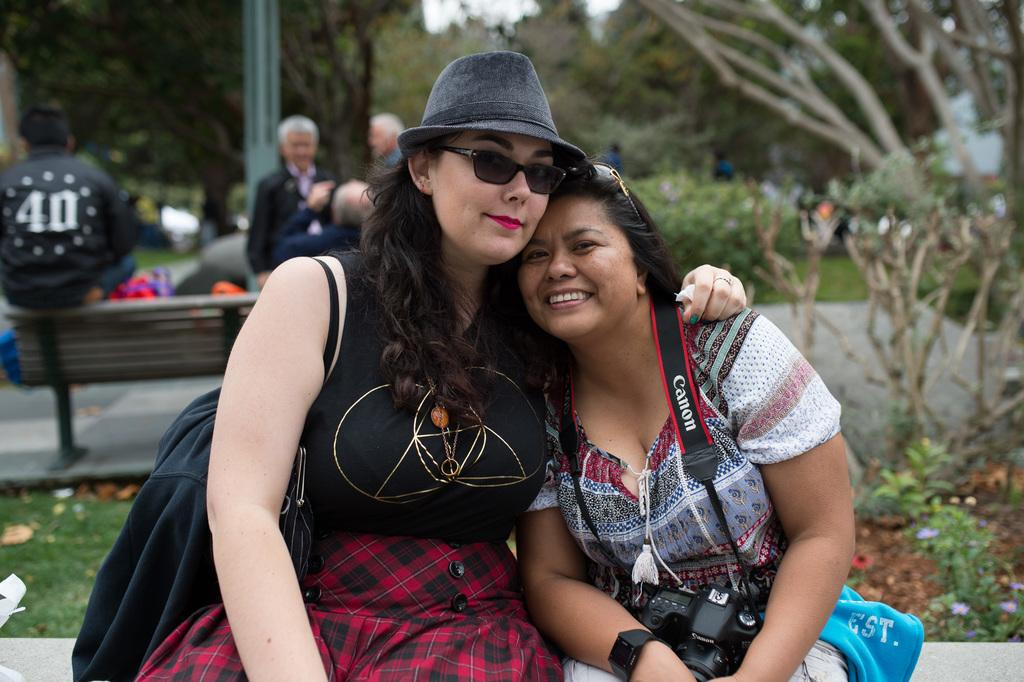How many people are in the image? There are people in the image, but the exact number is not specified. What is located in the background of the image? There is a bench and trees in the background of the image. What is the average income of the people in the image? There is no information about the income of the people in the image. Is there any dirt visible on the bench in the image? The presence or absence of dirt on the bench cannot be determined from the image. 